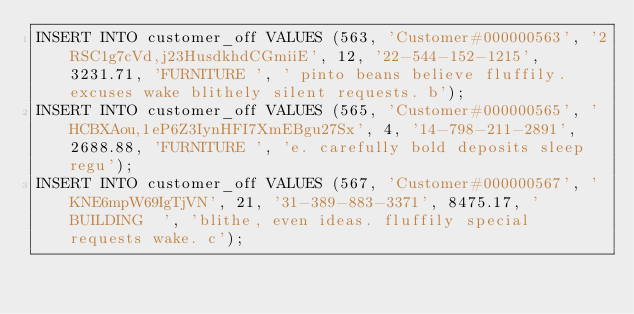Convert code to text. <code><loc_0><loc_0><loc_500><loc_500><_SQL_>INSERT INTO customer_off VALUES (563, 'Customer#000000563', '2RSC1g7cVd,j23HusdkhdCGmiiE', 12, '22-544-152-1215', 3231.71, 'FURNITURE ', ' pinto beans believe fluffily. excuses wake blithely silent requests. b');
INSERT INTO customer_off VALUES (565, 'Customer#000000565', 'HCBXAou,1eP6Z3IynHFI7XmEBgu27Sx', 4, '14-798-211-2891', 2688.88, 'FURNITURE ', 'e. carefully bold deposits sleep regu');
INSERT INTO customer_off VALUES (567, 'Customer#000000567', 'KNE6mpW69IgTjVN', 21, '31-389-883-3371', 8475.17, 'BUILDING  ', 'blithe, even ideas. fluffily special requests wake. c');</code> 